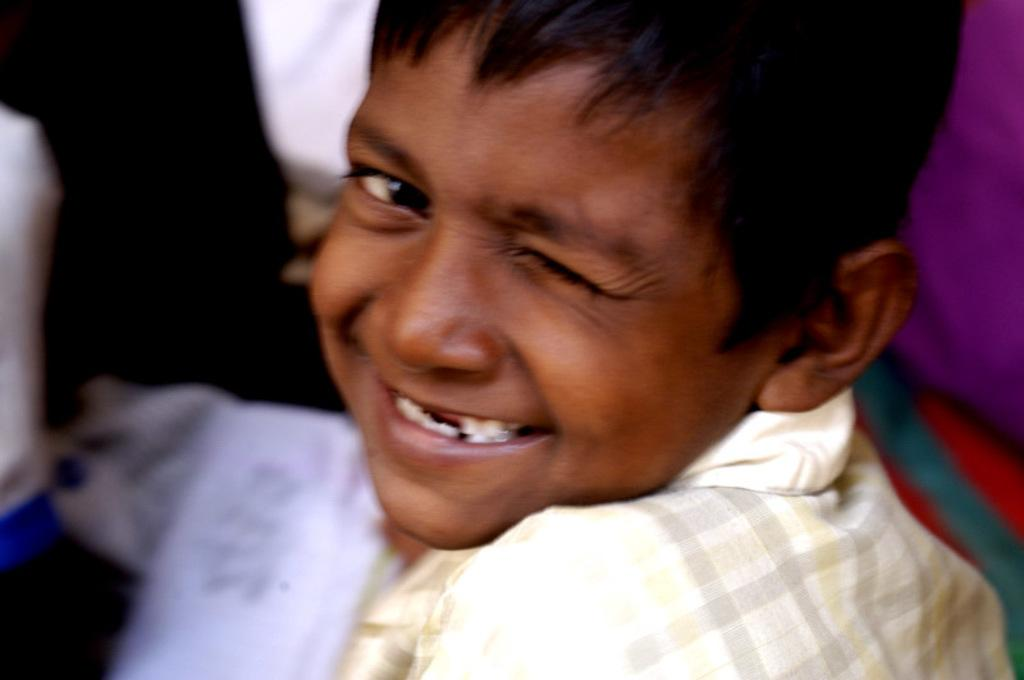What is the main subject of the image? The main subject of the image is a boy. What is the boy doing in the image? The boy is closing one of his eyes and smiling. Are there any other people in the image? Yes, there are other persons in the image, but they are not clearly visible. What type of organization is the boy a part of in the image? There is no indication in the image that the boy is a part of any organization. What is the relationship between the boy and the girl in the image? There is no girl present in the image, so it is not possible to determine any relationship between the boy and a girl. 